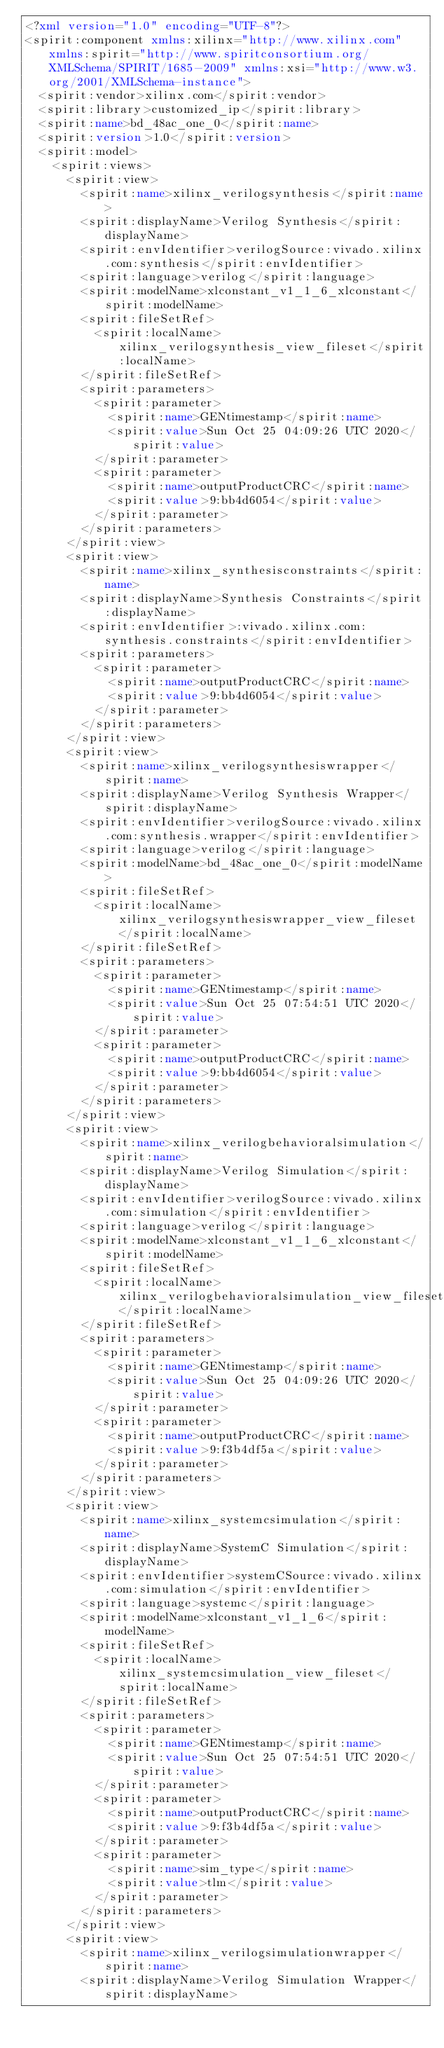Convert code to text. <code><loc_0><loc_0><loc_500><loc_500><_XML_><?xml version="1.0" encoding="UTF-8"?>
<spirit:component xmlns:xilinx="http://www.xilinx.com" xmlns:spirit="http://www.spiritconsortium.org/XMLSchema/SPIRIT/1685-2009" xmlns:xsi="http://www.w3.org/2001/XMLSchema-instance">
  <spirit:vendor>xilinx.com</spirit:vendor>
  <spirit:library>customized_ip</spirit:library>
  <spirit:name>bd_48ac_one_0</spirit:name>
  <spirit:version>1.0</spirit:version>
  <spirit:model>
    <spirit:views>
      <spirit:view>
        <spirit:name>xilinx_verilogsynthesis</spirit:name>
        <spirit:displayName>Verilog Synthesis</spirit:displayName>
        <spirit:envIdentifier>verilogSource:vivado.xilinx.com:synthesis</spirit:envIdentifier>
        <spirit:language>verilog</spirit:language>
        <spirit:modelName>xlconstant_v1_1_6_xlconstant</spirit:modelName>
        <spirit:fileSetRef>
          <spirit:localName>xilinx_verilogsynthesis_view_fileset</spirit:localName>
        </spirit:fileSetRef>
        <spirit:parameters>
          <spirit:parameter>
            <spirit:name>GENtimestamp</spirit:name>
            <spirit:value>Sun Oct 25 04:09:26 UTC 2020</spirit:value>
          </spirit:parameter>
          <spirit:parameter>
            <spirit:name>outputProductCRC</spirit:name>
            <spirit:value>9:bb4d6054</spirit:value>
          </spirit:parameter>
        </spirit:parameters>
      </spirit:view>
      <spirit:view>
        <spirit:name>xilinx_synthesisconstraints</spirit:name>
        <spirit:displayName>Synthesis Constraints</spirit:displayName>
        <spirit:envIdentifier>:vivado.xilinx.com:synthesis.constraints</spirit:envIdentifier>
        <spirit:parameters>
          <spirit:parameter>
            <spirit:name>outputProductCRC</spirit:name>
            <spirit:value>9:bb4d6054</spirit:value>
          </spirit:parameter>
        </spirit:parameters>
      </spirit:view>
      <spirit:view>
        <spirit:name>xilinx_verilogsynthesiswrapper</spirit:name>
        <spirit:displayName>Verilog Synthesis Wrapper</spirit:displayName>
        <spirit:envIdentifier>verilogSource:vivado.xilinx.com:synthesis.wrapper</spirit:envIdentifier>
        <spirit:language>verilog</spirit:language>
        <spirit:modelName>bd_48ac_one_0</spirit:modelName>
        <spirit:fileSetRef>
          <spirit:localName>xilinx_verilogsynthesiswrapper_view_fileset</spirit:localName>
        </spirit:fileSetRef>
        <spirit:parameters>
          <spirit:parameter>
            <spirit:name>GENtimestamp</spirit:name>
            <spirit:value>Sun Oct 25 07:54:51 UTC 2020</spirit:value>
          </spirit:parameter>
          <spirit:parameter>
            <spirit:name>outputProductCRC</spirit:name>
            <spirit:value>9:bb4d6054</spirit:value>
          </spirit:parameter>
        </spirit:parameters>
      </spirit:view>
      <spirit:view>
        <spirit:name>xilinx_verilogbehavioralsimulation</spirit:name>
        <spirit:displayName>Verilog Simulation</spirit:displayName>
        <spirit:envIdentifier>verilogSource:vivado.xilinx.com:simulation</spirit:envIdentifier>
        <spirit:language>verilog</spirit:language>
        <spirit:modelName>xlconstant_v1_1_6_xlconstant</spirit:modelName>
        <spirit:fileSetRef>
          <spirit:localName>xilinx_verilogbehavioralsimulation_view_fileset</spirit:localName>
        </spirit:fileSetRef>
        <spirit:parameters>
          <spirit:parameter>
            <spirit:name>GENtimestamp</spirit:name>
            <spirit:value>Sun Oct 25 04:09:26 UTC 2020</spirit:value>
          </spirit:parameter>
          <spirit:parameter>
            <spirit:name>outputProductCRC</spirit:name>
            <spirit:value>9:f3b4df5a</spirit:value>
          </spirit:parameter>
        </spirit:parameters>
      </spirit:view>
      <spirit:view>
        <spirit:name>xilinx_systemcsimulation</spirit:name>
        <spirit:displayName>SystemC Simulation</spirit:displayName>
        <spirit:envIdentifier>systemCSource:vivado.xilinx.com:simulation</spirit:envIdentifier>
        <spirit:language>systemc</spirit:language>
        <spirit:modelName>xlconstant_v1_1_6</spirit:modelName>
        <spirit:fileSetRef>
          <spirit:localName>xilinx_systemcsimulation_view_fileset</spirit:localName>
        </spirit:fileSetRef>
        <spirit:parameters>
          <spirit:parameter>
            <spirit:name>GENtimestamp</spirit:name>
            <spirit:value>Sun Oct 25 07:54:51 UTC 2020</spirit:value>
          </spirit:parameter>
          <spirit:parameter>
            <spirit:name>outputProductCRC</spirit:name>
            <spirit:value>9:f3b4df5a</spirit:value>
          </spirit:parameter>
          <spirit:parameter>
            <spirit:name>sim_type</spirit:name>
            <spirit:value>tlm</spirit:value>
          </spirit:parameter>
        </spirit:parameters>
      </spirit:view>
      <spirit:view>
        <spirit:name>xilinx_verilogsimulationwrapper</spirit:name>
        <spirit:displayName>Verilog Simulation Wrapper</spirit:displayName></code> 